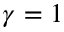Convert formula to latex. <formula><loc_0><loc_0><loc_500><loc_500>\gamma = 1</formula> 